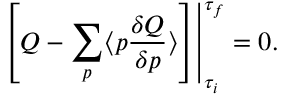<formula> <loc_0><loc_0><loc_500><loc_500>\left [ Q - \sum _ { p } \langle p { \frac { \delta Q } { \delta p } } \rangle \right ] \right | _ { { \tau _ { i } } } ^ { \tau _ { f } } = 0 .</formula> 